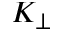Convert formula to latex. <formula><loc_0><loc_0><loc_500><loc_500>K _ { \perp }</formula> 